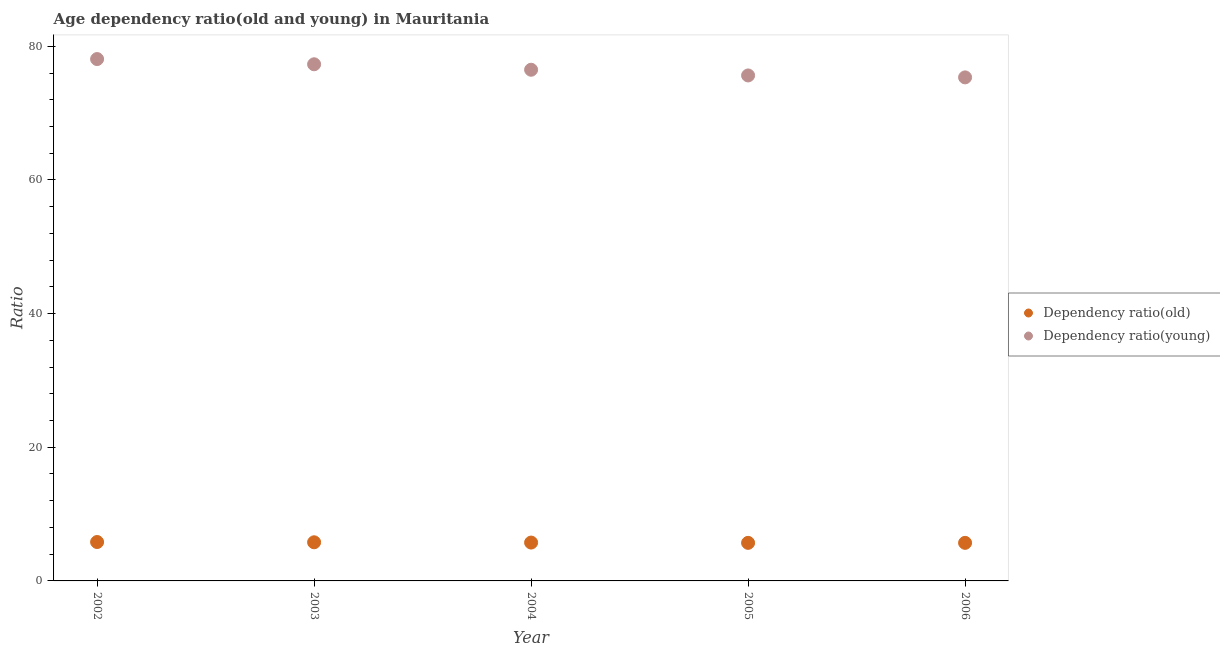How many different coloured dotlines are there?
Your response must be concise. 2. What is the age dependency ratio(young) in 2004?
Ensure brevity in your answer.  76.49. Across all years, what is the maximum age dependency ratio(young)?
Your answer should be compact. 78.09. Across all years, what is the minimum age dependency ratio(young)?
Your response must be concise. 75.35. In which year was the age dependency ratio(young) maximum?
Make the answer very short. 2002. What is the total age dependency ratio(old) in the graph?
Offer a terse response. 28.74. What is the difference between the age dependency ratio(old) in 2002 and that in 2006?
Your answer should be compact. 0.12. What is the difference between the age dependency ratio(young) in 2006 and the age dependency ratio(old) in 2004?
Provide a succinct answer. 69.61. What is the average age dependency ratio(old) per year?
Give a very brief answer. 5.75. In the year 2003, what is the difference between the age dependency ratio(old) and age dependency ratio(young)?
Your answer should be very brief. -71.53. What is the ratio of the age dependency ratio(young) in 2004 to that in 2006?
Provide a short and direct response. 1.02. Is the age dependency ratio(old) in 2002 less than that in 2004?
Your answer should be very brief. No. What is the difference between the highest and the second highest age dependency ratio(young)?
Your answer should be very brief. 0.78. What is the difference between the highest and the lowest age dependency ratio(old)?
Offer a very short reply. 0.13. In how many years, is the age dependency ratio(young) greater than the average age dependency ratio(young) taken over all years?
Make the answer very short. 2. What is the difference between two consecutive major ticks on the Y-axis?
Provide a short and direct response. 20. Are the values on the major ticks of Y-axis written in scientific E-notation?
Provide a succinct answer. No. Does the graph contain grids?
Ensure brevity in your answer.  No. What is the title of the graph?
Offer a very short reply. Age dependency ratio(old and young) in Mauritania. Does "Primary income" appear as one of the legend labels in the graph?
Make the answer very short. No. What is the label or title of the X-axis?
Offer a terse response. Year. What is the label or title of the Y-axis?
Offer a terse response. Ratio. What is the Ratio in Dependency ratio(old) in 2002?
Make the answer very short. 5.82. What is the Ratio of Dependency ratio(young) in 2002?
Offer a terse response. 78.09. What is the Ratio of Dependency ratio(old) in 2003?
Give a very brief answer. 5.78. What is the Ratio in Dependency ratio(young) in 2003?
Provide a short and direct response. 77.31. What is the Ratio in Dependency ratio(old) in 2004?
Give a very brief answer. 5.74. What is the Ratio in Dependency ratio(young) in 2004?
Provide a short and direct response. 76.49. What is the Ratio of Dependency ratio(old) in 2005?
Provide a succinct answer. 5.7. What is the Ratio of Dependency ratio(young) in 2005?
Offer a terse response. 75.64. What is the Ratio in Dependency ratio(old) in 2006?
Your answer should be compact. 5.7. What is the Ratio in Dependency ratio(young) in 2006?
Offer a terse response. 75.35. Across all years, what is the maximum Ratio of Dependency ratio(old)?
Provide a succinct answer. 5.82. Across all years, what is the maximum Ratio of Dependency ratio(young)?
Provide a short and direct response. 78.09. Across all years, what is the minimum Ratio of Dependency ratio(old)?
Your answer should be compact. 5.7. Across all years, what is the minimum Ratio of Dependency ratio(young)?
Ensure brevity in your answer.  75.35. What is the total Ratio in Dependency ratio(old) in the graph?
Offer a very short reply. 28.74. What is the total Ratio in Dependency ratio(young) in the graph?
Provide a succinct answer. 382.88. What is the difference between the Ratio of Dependency ratio(old) in 2002 and that in 2003?
Provide a short and direct response. 0.04. What is the difference between the Ratio of Dependency ratio(young) in 2002 and that in 2003?
Ensure brevity in your answer.  0.78. What is the difference between the Ratio in Dependency ratio(old) in 2002 and that in 2004?
Ensure brevity in your answer.  0.08. What is the difference between the Ratio of Dependency ratio(young) in 2002 and that in 2004?
Your answer should be very brief. 1.6. What is the difference between the Ratio of Dependency ratio(old) in 2002 and that in 2005?
Provide a short and direct response. 0.13. What is the difference between the Ratio of Dependency ratio(young) in 2002 and that in 2005?
Your response must be concise. 2.45. What is the difference between the Ratio in Dependency ratio(old) in 2002 and that in 2006?
Provide a succinct answer. 0.12. What is the difference between the Ratio in Dependency ratio(young) in 2002 and that in 2006?
Provide a succinct answer. 2.74. What is the difference between the Ratio in Dependency ratio(old) in 2003 and that in 2004?
Provide a short and direct response. 0.04. What is the difference between the Ratio of Dependency ratio(young) in 2003 and that in 2004?
Provide a succinct answer. 0.82. What is the difference between the Ratio in Dependency ratio(old) in 2003 and that in 2005?
Make the answer very short. 0.09. What is the difference between the Ratio of Dependency ratio(young) in 2003 and that in 2005?
Give a very brief answer. 1.67. What is the difference between the Ratio in Dependency ratio(old) in 2003 and that in 2006?
Offer a very short reply. 0.08. What is the difference between the Ratio of Dependency ratio(young) in 2003 and that in 2006?
Provide a short and direct response. 1.96. What is the difference between the Ratio in Dependency ratio(old) in 2004 and that in 2005?
Make the answer very short. 0.04. What is the difference between the Ratio of Dependency ratio(young) in 2004 and that in 2005?
Make the answer very short. 0.85. What is the difference between the Ratio of Dependency ratio(old) in 2004 and that in 2006?
Your response must be concise. 0.04. What is the difference between the Ratio of Dependency ratio(young) in 2004 and that in 2006?
Provide a short and direct response. 1.14. What is the difference between the Ratio in Dependency ratio(old) in 2005 and that in 2006?
Provide a succinct answer. -0. What is the difference between the Ratio in Dependency ratio(young) in 2005 and that in 2006?
Your response must be concise. 0.29. What is the difference between the Ratio of Dependency ratio(old) in 2002 and the Ratio of Dependency ratio(young) in 2003?
Your response must be concise. -71.49. What is the difference between the Ratio in Dependency ratio(old) in 2002 and the Ratio in Dependency ratio(young) in 2004?
Ensure brevity in your answer.  -70.67. What is the difference between the Ratio in Dependency ratio(old) in 2002 and the Ratio in Dependency ratio(young) in 2005?
Your answer should be compact. -69.82. What is the difference between the Ratio in Dependency ratio(old) in 2002 and the Ratio in Dependency ratio(young) in 2006?
Provide a short and direct response. -69.53. What is the difference between the Ratio in Dependency ratio(old) in 2003 and the Ratio in Dependency ratio(young) in 2004?
Provide a short and direct response. -70.71. What is the difference between the Ratio of Dependency ratio(old) in 2003 and the Ratio of Dependency ratio(young) in 2005?
Your answer should be compact. -69.86. What is the difference between the Ratio in Dependency ratio(old) in 2003 and the Ratio in Dependency ratio(young) in 2006?
Your answer should be very brief. -69.57. What is the difference between the Ratio in Dependency ratio(old) in 2004 and the Ratio in Dependency ratio(young) in 2005?
Your answer should be compact. -69.9. What is the difference between the Ratio of Dependency ratio(old) in 2004 and the Ratio of Dependency ratio(young) in 2006?
Offer a very short reply. -69.61. What is the difference between the Ratio in Dependency ratio(old) in 2005 and the Ratio in Dependency ratio(young) in 2006?
Offer a terse response. -69.65. What is the average Ratio in Dependency ratio(old) per year?
Your response must be concise. 5.75. What is the average Ratio in Dependency ratio(young) per year?
Offer a terse response. 76.58. In the year 2002, what is the difference between the Ratio of Dependency ratio(old) and Ratio of Dependency ratio(young)?
Offer a terse response. -72.27. In the year 2003, what is the difference between the Ratio of Dependency ratio(old) and Ratio of Dependency ratio(young)?
Your answer should be compact. -71.53. In the year 2004, what is the difference between the Ratio in Dependency ratio(old) and Ratio in Dependency ratio(young)?
Ensure brevity in your answer.  -70.75. In the year 2005, what is the difference between the Ratio in Dependency ratio(old) and Ratio in Dependency ratio(young)?
Provide a succinct answer. -69.94. In the year 2006, what is the difference between the Ratio of Dependency ratio(old) and Ratio of Dependency ratio(young)?
Your response must be concise. -69.65. What is the ratio of the Ratio of Dependency ratio(old) in 2002 to that in 2003?
Make the answer very short. 1.01. What is the ratio of the Ratio in Dependency ratio(old) in 2002 to that in 2004?
Your response must be concise. 1.01. What is the ratio of the Ratio of Dependency ratio(young) in 2002 to that in 2004?
Provide a short and direct response. 1.02. What is the ratio of the Ratio in Dependency ratio(old) in 2002 to that in 2005?
Your response must be concise. 1.02. What is the ratio of the Ratio in Dependency ratio(young) in 2002 to that in 2005?
Provide a short and direct response. 1.03. What is the ratio of the Ratio in Dependency ratio(old) in 2002 to that in 2006?
Give a very brief answer. 1.02. What is the ratio of the Ratio in Dependency ratio(young) in 2002 to that in 2006?
Make the answer very short. 1.04. What is the ratio of the Ratio in Dependency ratio(old) in 2003 to that in 2004?
Offer a terse response. 1.01. What is the ratio of the Ratio in Dependency ratio(young) in 2003 to that in 2004?
Your answer should be compact. 1.01. What is the ratio of the Ratio in Dependency ratio(young) in 2003 to that in 2005?
Keep it short and to the point. 1.02. What is the ratio of the Ratio of Dependency ratio(old) in 2003 to that in 2006?
Keep it short and to the point. 1.01. What is the ratio of the Ratio of Dependency ratio(young) in 2003 to that in 2006?
Provide a short and direct response. 1.03. What is the ratio of the Ratio of Dependency ratio(old) in 2004 to that in 2005?
Provide a succinct answer. 1.01. What is the ratio of the Ratio in Dependency ratio(young) in 2004 to that in 2005?
Provide a succinct answer. 1.01. What is the ratio of the Ratio in Dependency ratio(old) in 2004 to that in 2006?
Keep it short and to the point. 1.01. What is the ratio of the Ratio of Dependency ratio(young) in 2004 to that in 2006?
Your answer should be compact. 1.02. What is the ratio of the Ratio in Dependency ratio(young) in 2005 to that in 2006?
Make the answer very short. 1. What is the difference between the highest and the second highest Ratio in Dependency ratio(old)?
Offer a very short reply. 0.04. What is the difference between the highest and the second highest Ratio of Dependency ratio(young)?
Your answer should be very brief. 0.78. What is the difference between the highest and the lowest Ratio of Dependency ratio(old)?
Your answer should be compact. 0.13. What is the difference between the highest and the lowest Ratio in Dependency ratio(young)?
Make the answer very short. 2.74. 